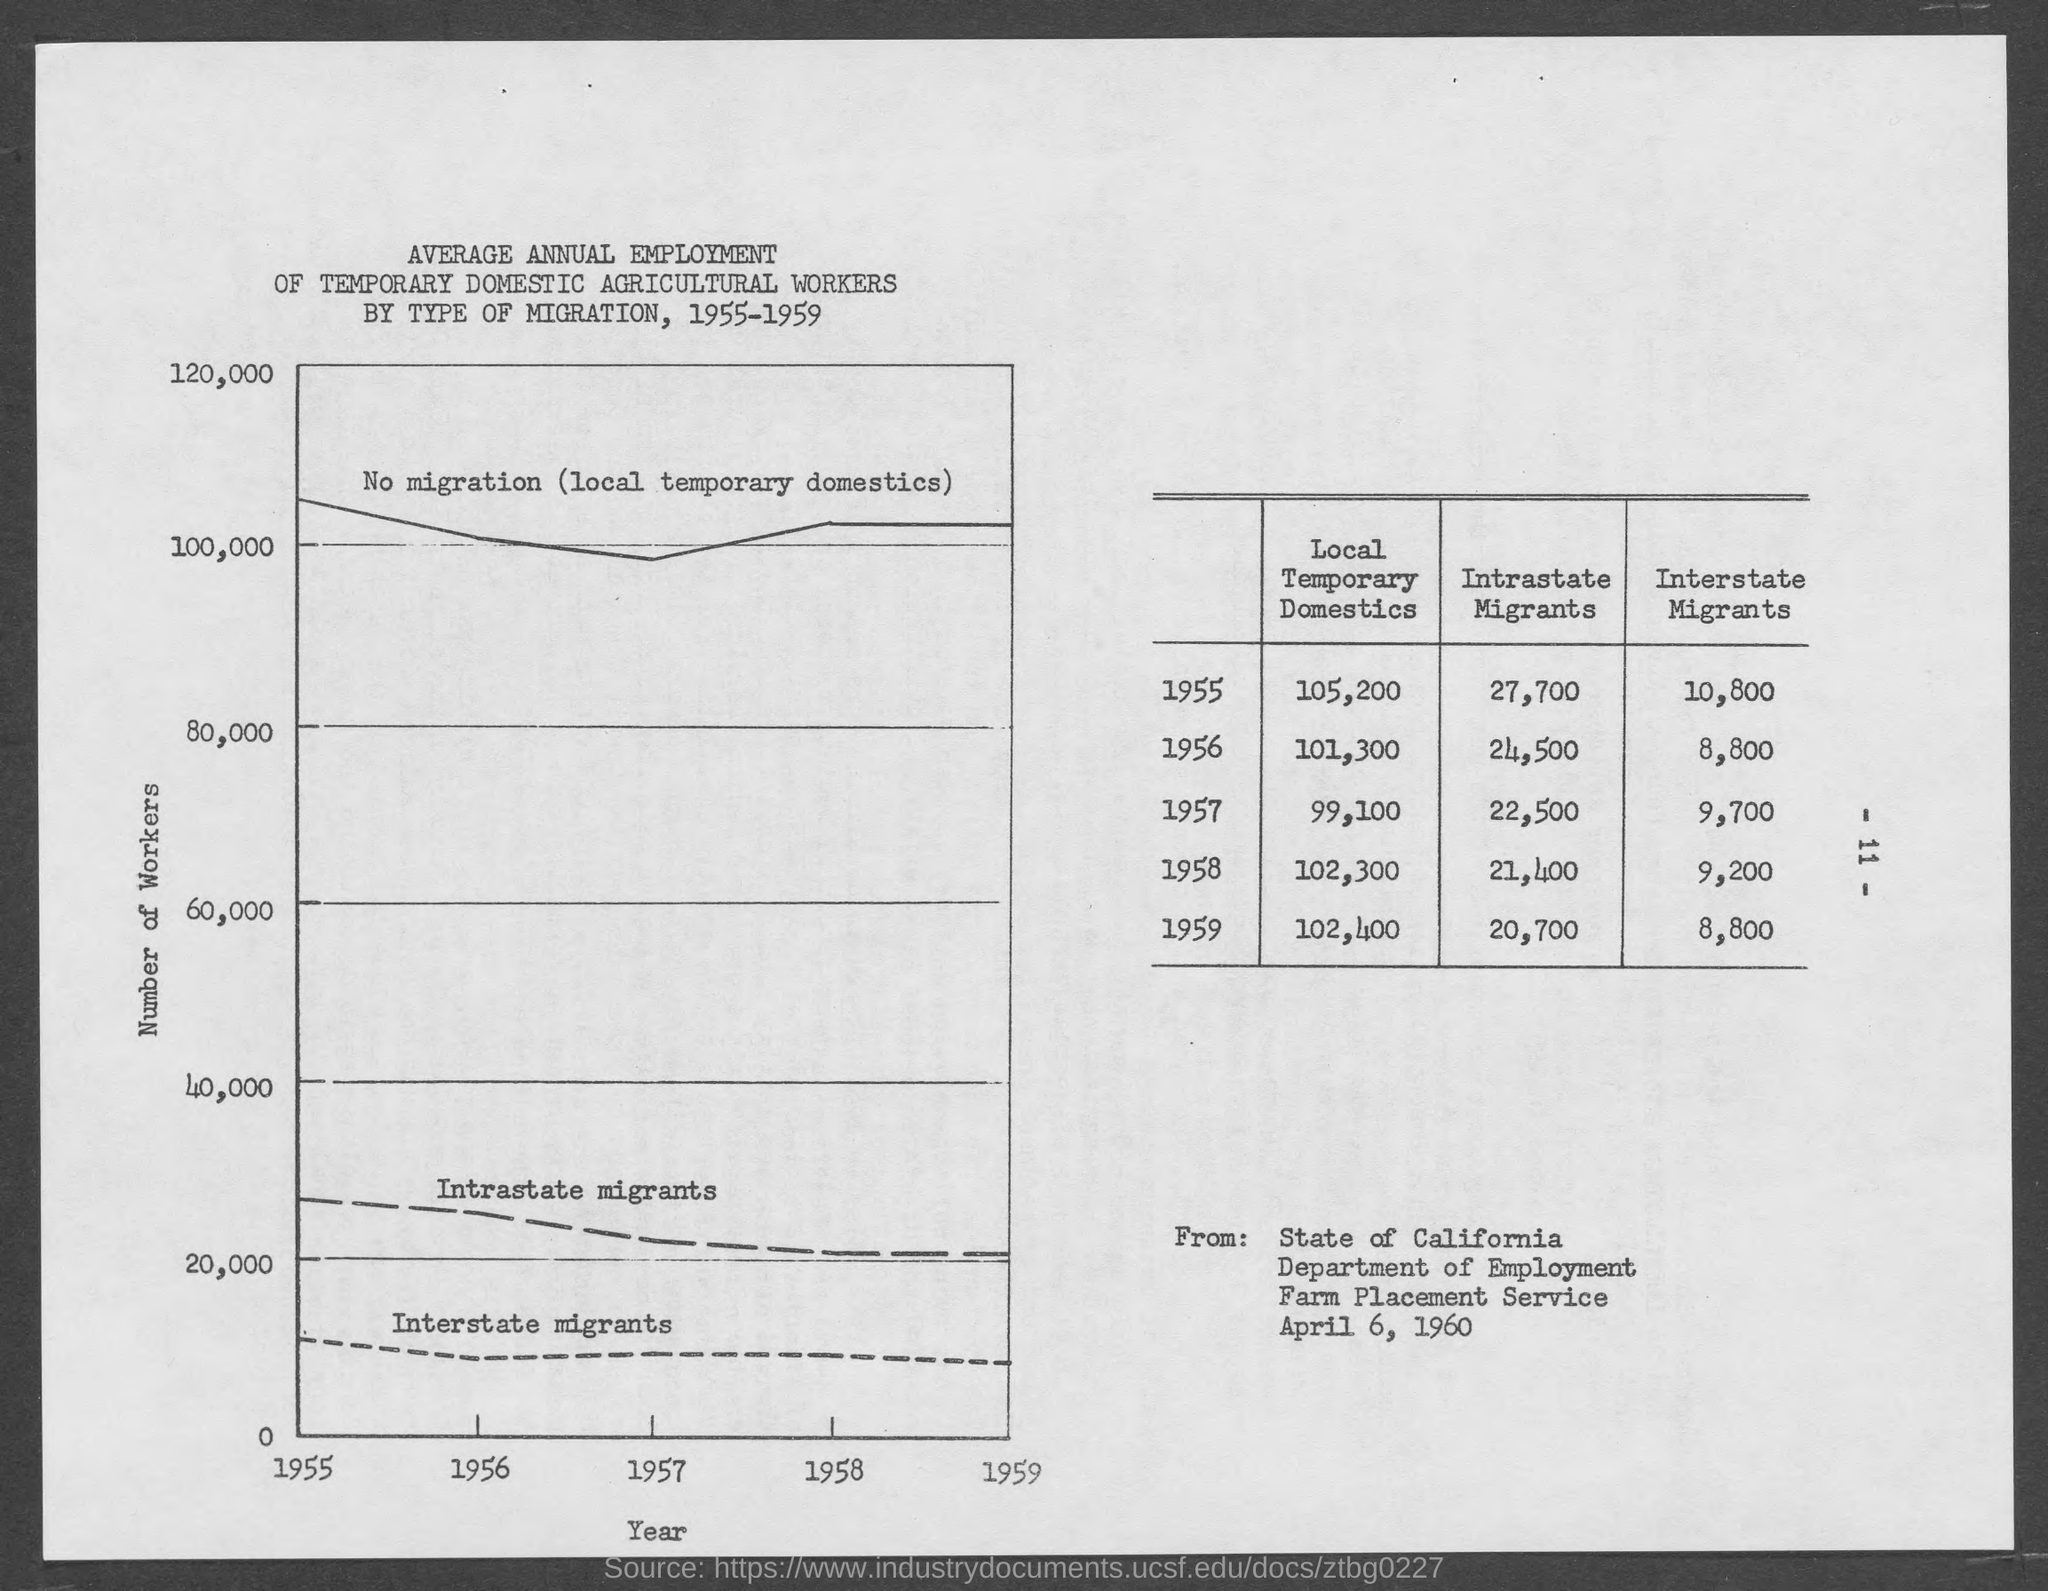What is given on x- axis ?
Offer a terse response. Year. What is given on y- axis ?
Your response must be concise. Number of Workers. 